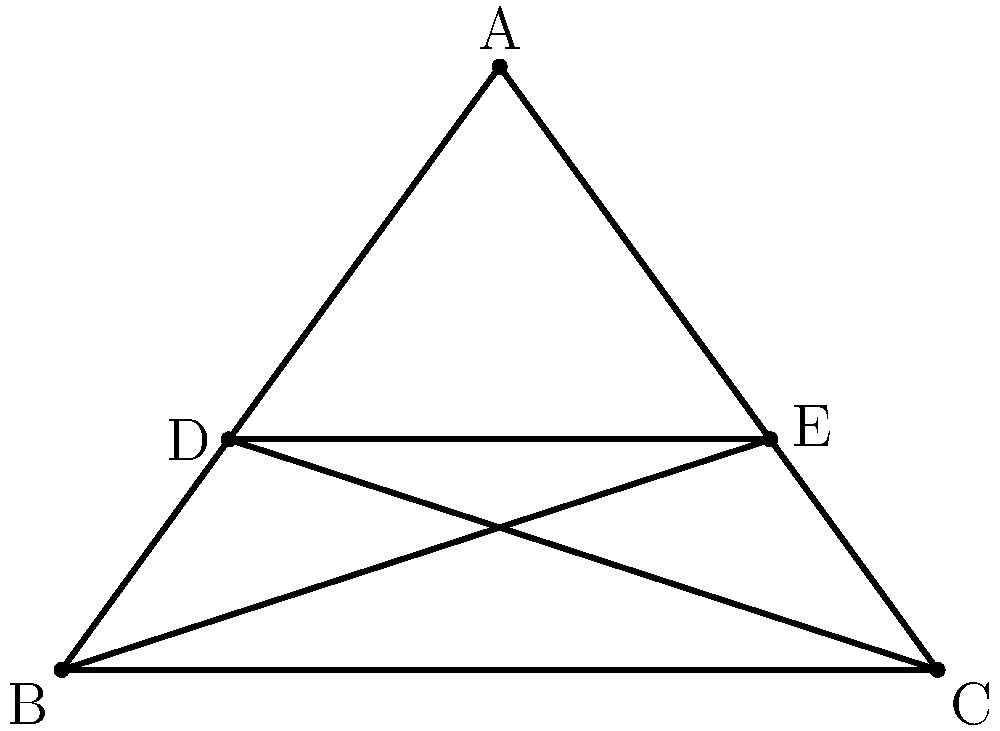In designing a pentagram for a heavy metal band logo tattoo, you need to determine the measure of each interior angle. Given that a pentagram is a regular star polygon, calculate the measure of one interior angle of this pentagram. To find the measure of an interior angle in a pentagram, we can follow these steps:

1) First, recall that a pentagram is formed by extending the sides of a regular pentagon.

2) In a regular pentagon, each interior angle measures:
   $$\frac{(n-2) \times 180°}{n} = \frac{(5-2) \times 180°}{5} = 108°$$

3) The pentagram divides each of these 108° angles into two equal parts.

4) Therefore, the angle at each point of the star (like angle BAE) is:
   $$108° \div 2 = 54°$$

5) The interior angle of the pentagram we're looking for is supplementary to this 54° angle.

6) To find a supplementary angle, we subtract from 180°:
   $$180° - 54° = 126°$$

Thus, each interior angle of the pentagram (like angle ABC) measures 126°.
Answer: 126° 